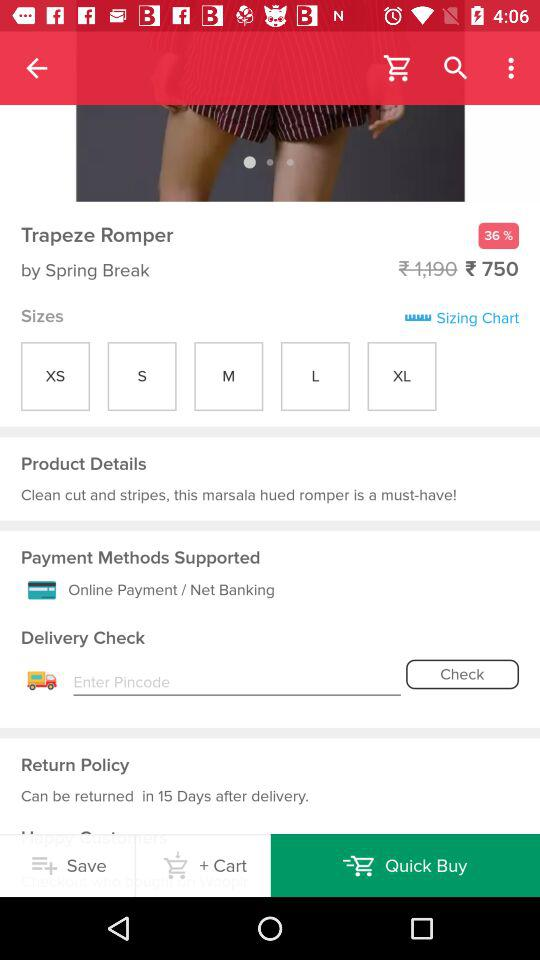How much of a discount is available? The discount is 36%. 